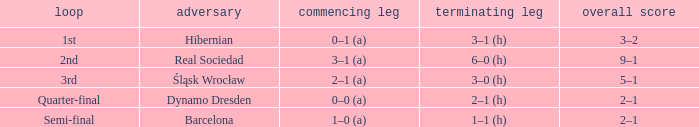What was the first leg of the semi-final? 1–0 (a). 